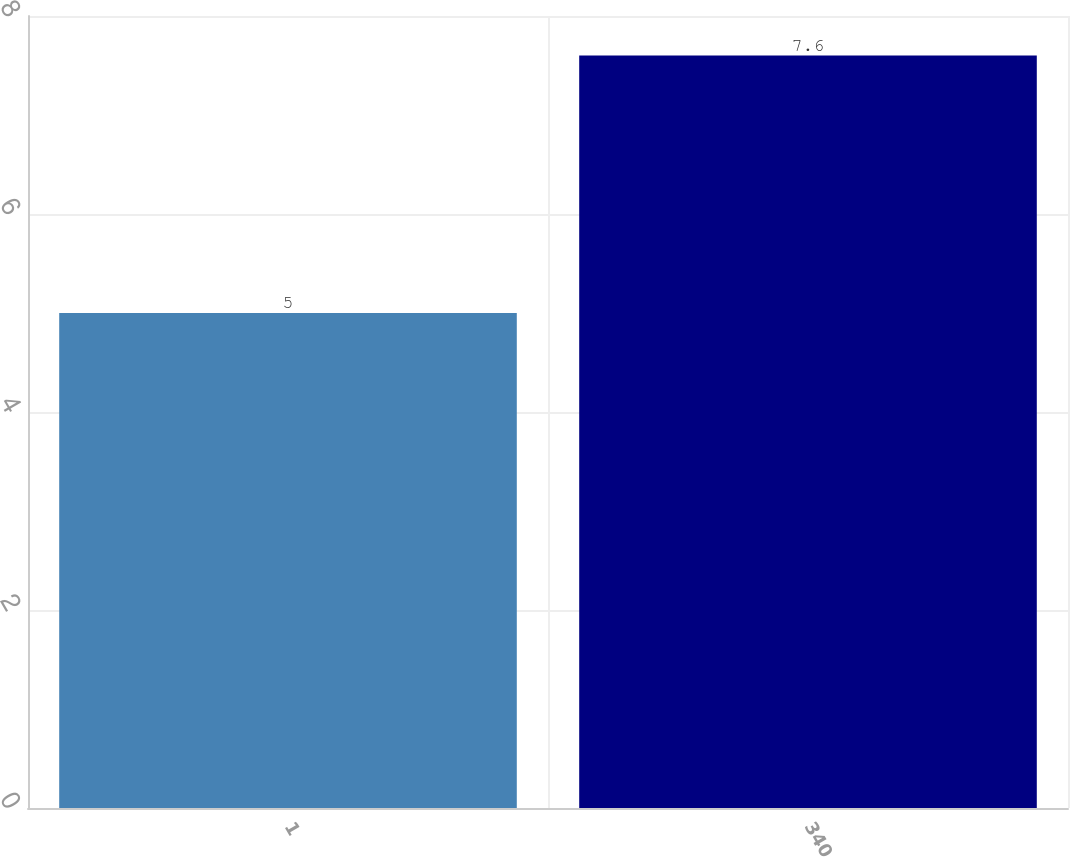<chart> <loc_0><loc_0><loc_500><loc_500><bar_chart><fcel>1<fcel>340<nl><fcel>5<fcel>7.6<nl></chart> 